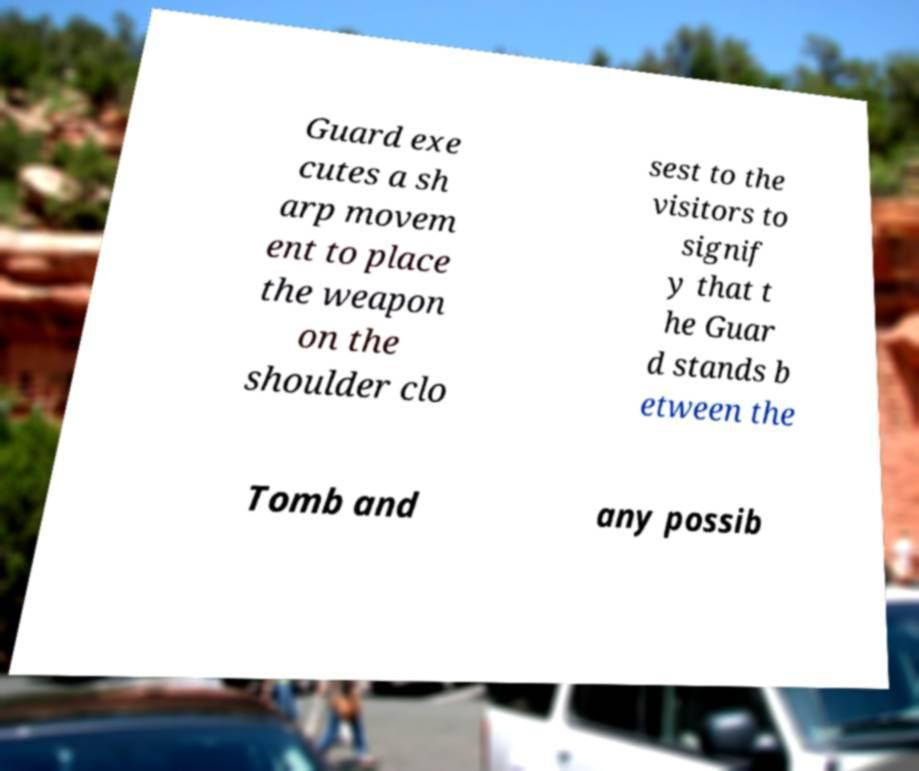Please read and relay the text visible in this image. What does it say? Guard exe cutes a sh arp movem ent to place the weapon on the shoulder clo sest to the visitors to signif y that t he Guar d stands b etween the Tomb and any possib 